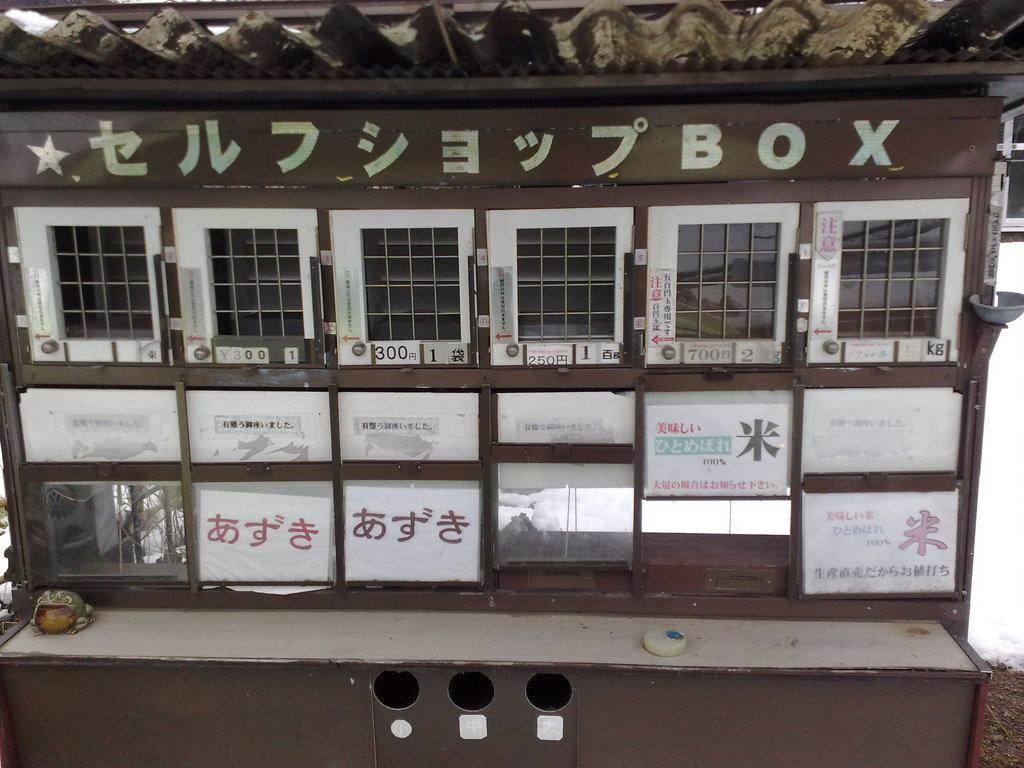<image>
Provide a brief description of the given image. A brown metal Box with the numbers 700, 250, and 300 on it 